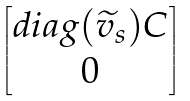<formula> <loc_0><loc_0><loc_500><loc_500>\begin{bmatrix} d i a g ( \widetilde { v } _ { s } ) C \\ 0 \end{bmatrix}</formula> 